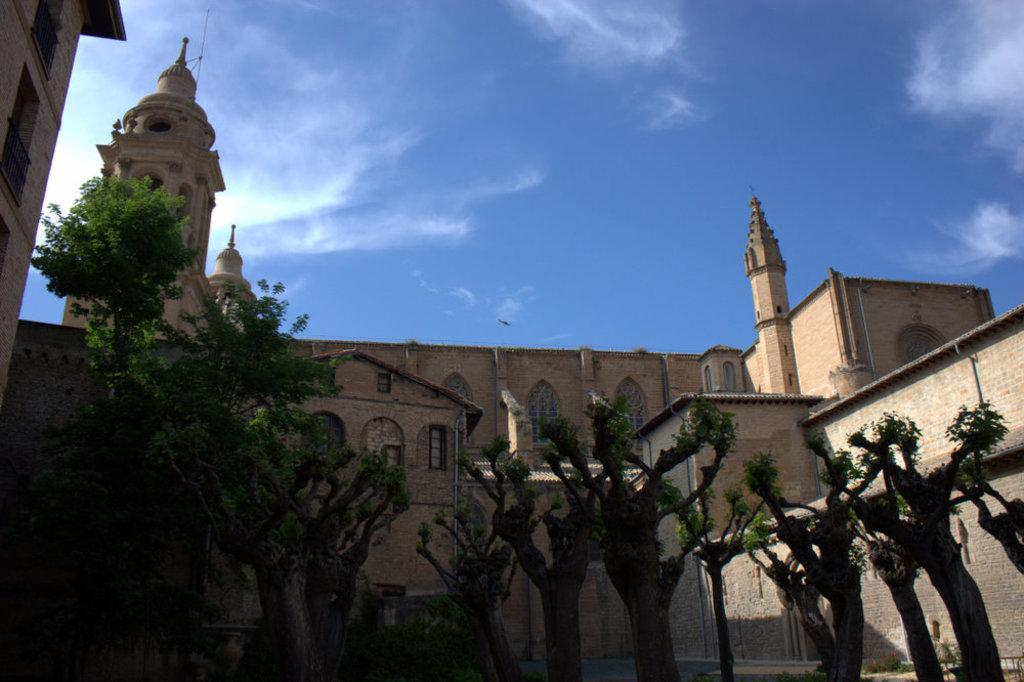What type of vegetation is present in the image? There are many trees in the image. What structure can be seen behind the trees? There is a building visible behind the trees. What is visible at the top of the image? The sky is visible at the top of the image. What can be observed in the sky? There are clouds in the sky. Where is the crate located in the image? There is no crate present in the image. What type of animal can be seen interacting with the trees in the image? There are no animals visible in the image; it only features trees, a building, the sky, and clouds. 